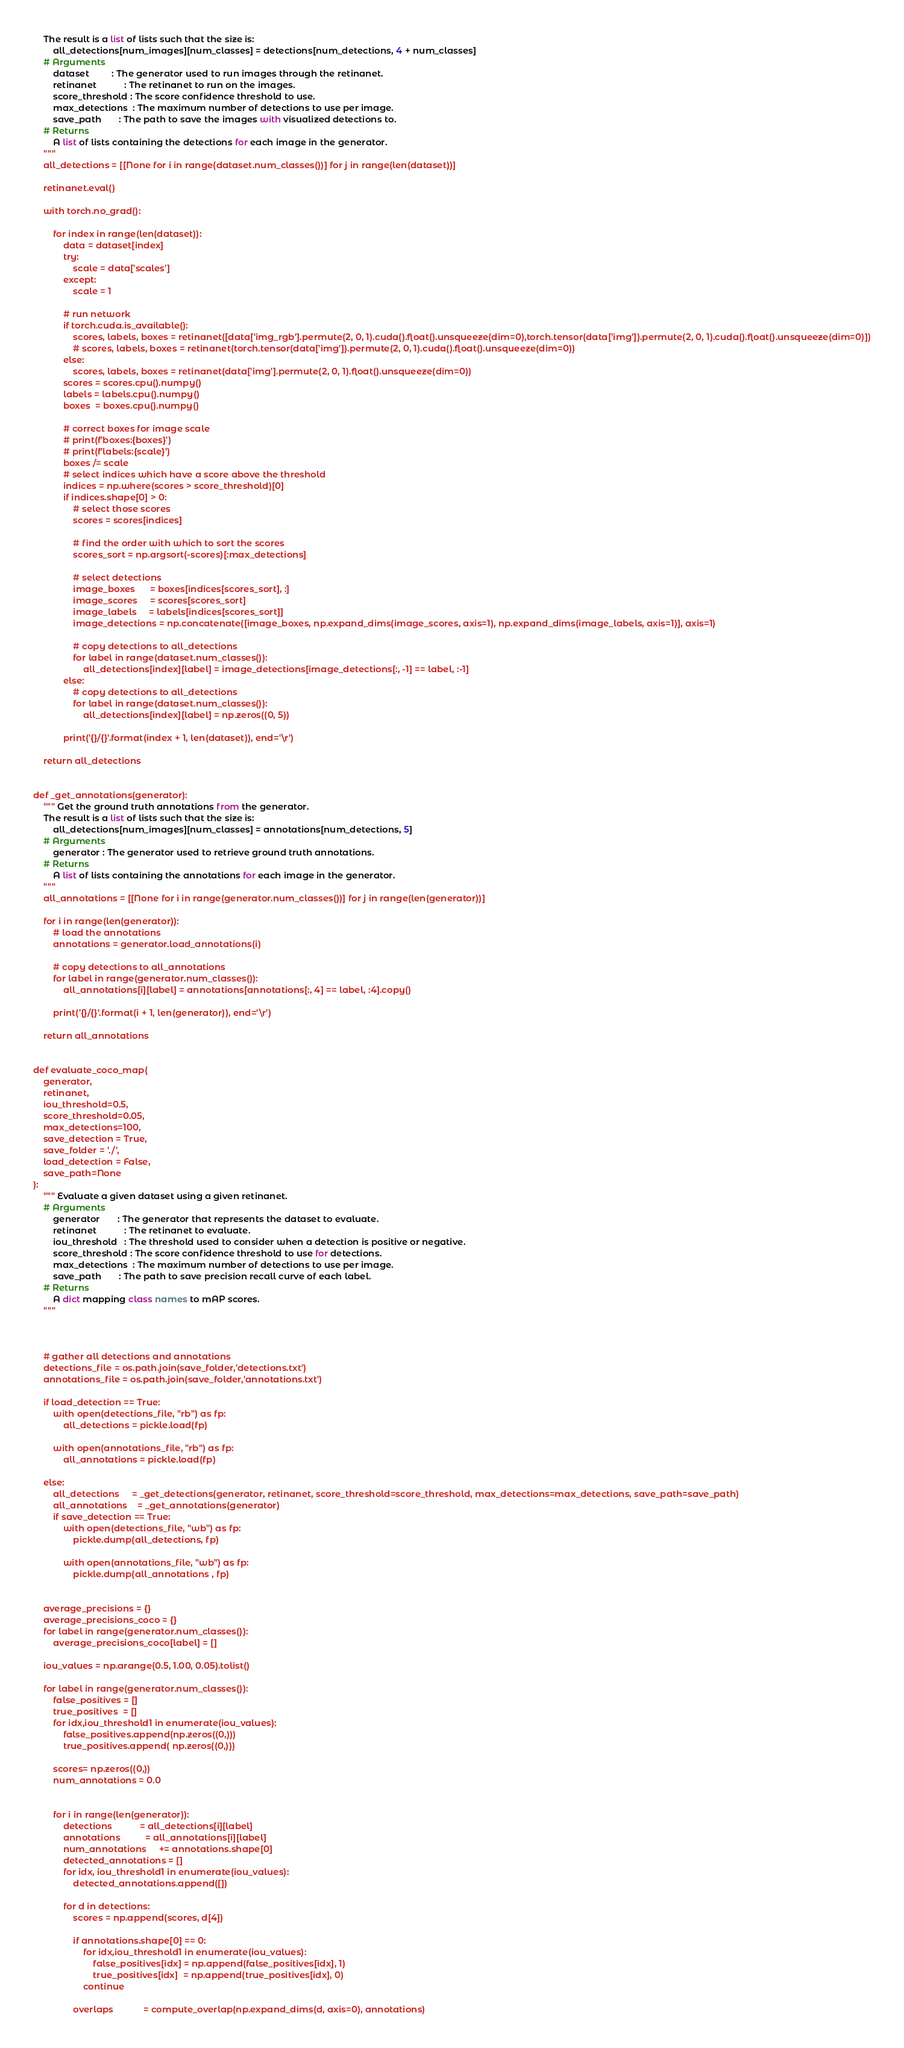<code> <loc_0><loc_0><loc_500><loc_500><_Python_>    The result is a list of lists such that the size is:
        all_detections[num_images][num_classes] = detections[num_detections, 4 + num_classes]
    # Arguments
        dataset         : The generator used to run images through the retinanet.
        retinanet           : The retinanet to run on the images.
        score_threshold : The score confidence threshold to use.
        max_detections  : The maximum number of detections to use per image.
        save_path       : The path to save the images with visualized detections to.
    # Returns
        A list of lists containing the detections for each image in the generator.
    """
    all_detections = [[None for i in range(dataset.num_classes())] for j in range(len(dataset))]

    retinanet.eval()
    
    with torch.no_grad():

        for index in range(len(dataset)):
            data = dataset[index]
            try:
                scale = data['scales']
            except:
                scale = 1

            # run network
            if torch.cuda.is_available():
                scores, labels, boxes = retinanet([data['img_rgb'].permute(2, 0, 1).cuda().float().unsqueeze(dim=0),torch.tensor(data['img']).permute(2, 0, 1).cuda().float().unsqueeze(dim=0)])
                # scores, labels, boxes = retinanet(torch.tensor(data['img']).permute(2, 0, 1).cuda().float().unsqueeze(dim=0))
            else:
                scores, labels, boxes = retinanet(data['img'].permute(2, 0, 1).float().unsqueeze(dim=0))
            scores = scores.cpu().numpy()
            labels = labels.cpu().numpy()
            boxes  = boxes.cpu().numpy()

            # correct boxes for image scale
            # print(f'boxes:{boxes}')
            # print(f'labels:{scale}')
            boxes /= scale
            # select indices which have a score above the threshold
            indices = np.where(scores > score_threshold)[0]
            if indices.shape[0] > 0:
                # select those scores
                scores = scores[indices]

                # find the order with which to sort the scores
                scores_sort = np.argsort(-scores)[:max_detections]

                # select detections
                image_boxes      = boxes[indices[scores_sort], :]
                image_scores     = scores[scores_sort]
                image_labels     = labels[indices[scores_sort]]
                image_detections = np.concatenate([image_boxes, np.expand_dims(image_scores, axis=1), np.expand_dims(image_labels, axis=1)], axis=1)

                # copy detections to all_detections
                for label in range(dataset.num_classes()):
                    all_detections[index][label] = image_detections[image_detections[:, -1] == label, :-1]
            else:
                # copy detections to all_detections
                for label in range(dataset.num_classes()):
                    all_detections[index][label] = np.zeros((0, 5))

            print('{}/{}'.format(index + 1, len(dataset)), end='\r')

    return all_detections


def _get_annotations(generator):
    """ Get the ground truth annotations from the generator.
    The result is a list of lists such that the size is:
        all_detections[num_images][num_classes] = annotations[num_detections, 5]
    # Arguments
        generator : The generator used to retrieve ground truth annotations.
    # Returns
        A list of lists containing the annotations for each image in the generator.
    """
    all_annotations = [[None for i in range(generator.num_classes())] for j in range(len(generator))]

    for i in range(len(generator)):
        # load the annotations
        annotations = generator.load_annotations(i)

        # copy detections to all_annotations
        for label in range(generator.num_classes()):
            all_annotations[i][label] = annotations[annotations[:, 4] == label, :4].copy()

        print('{}/{}'.format(i + 1, len(generator)), end='\r')

    return all_annotations


def evaluate_coco_map(
    generator,
    retinanet,
    iou_threshold=0.5,
    score_threshold=0.05,
    max_detections=100,
    save_detection = True,
    save_folder = './',
    load_detection = False,
    save_path=None
):
    """ Evaluate a given dataset using a given retinanet.
    # Arguments
        generator       : The generator that represents the dataset to evaluate.
        retinanet           : The retinanet to evaluate.
        iou_threshold   : The threshold used to consider when a detection is positive or negative.
        score_threshold : The score confidence threshold to use for detections.
        max_detections  : The maximum number of detections to use per image.
        save_path       : The path to save precision recall curve of each label.
    # Returns
        A dict mapping class names to mAP scores.
    """



    # gather all detections and annotations
    detections_file = os.path.join(save_folder,'detections.txt')
    annotations_file = os.path.join(save_folder,'annotations.txt')

    if load_detection == True:
        with open(detections_file, "rb") as fp:  
            all_detections = pickle.load(fp)

        with open(annotations_file, "rb") as fp: 
            all_annotations = pickle.load(fp)

    else:
        all_detections     = _get_detections(generator, retinanet, score_threshold=score_threshold, max_detections=max_detections, save_path=save_path)
        all_annotations    = _get_annotations(generator)
        if save_detection == True:
            with open(detections_file, "wb") as fp:
                pickle.dump(all_detections, fp)

            with open(annotations_file, "wb") as fp:
                pickle.dump(all_annotations , fp)


    average_precisions = {}
    average_precisions_coco = {}
    for label in range(generator.num_classes()):
        average_precisions_coco[label] = []

    iou_values = np.arange(0.5, 1.00, 0.05).tolist()

    for label in range(generator.num_classes()):
        false_positives = []
        true_positives  = []
        for idx,iou_threshold1 in enumerate(iou_values):
            false_positives.append(np.zeros((0,)))
            true_positives.append( np.zeros((0,)))

        scores= np.zeros((0,))
        num_annotations = 0.0

        
        for i in range(len(generator)):
            detections           = all_detections[i][label]
            annotations          = all_annotations[i][label]
            num_annotations     += annotations.shape[0]
            detected_annotations = []
            for idx, iou_threshold1 in enumerate(iou_values):
                detected_annotations.append([])

            for d in detections:
                scores = np.append(scores, d[4])

                if annotations.shape[0] == 0:
                    for idx,iou_threshold1 in enumerate(iou_values):
                        false_positives[idx] = np.append(false_positives[idx], 1)
                        true_positives[idx]  = np.append(true_positives[idx], 0)
                    continue

                overlaps            = compute_overlap(np.expand_dims(d, axis=0), annotations)</code> 